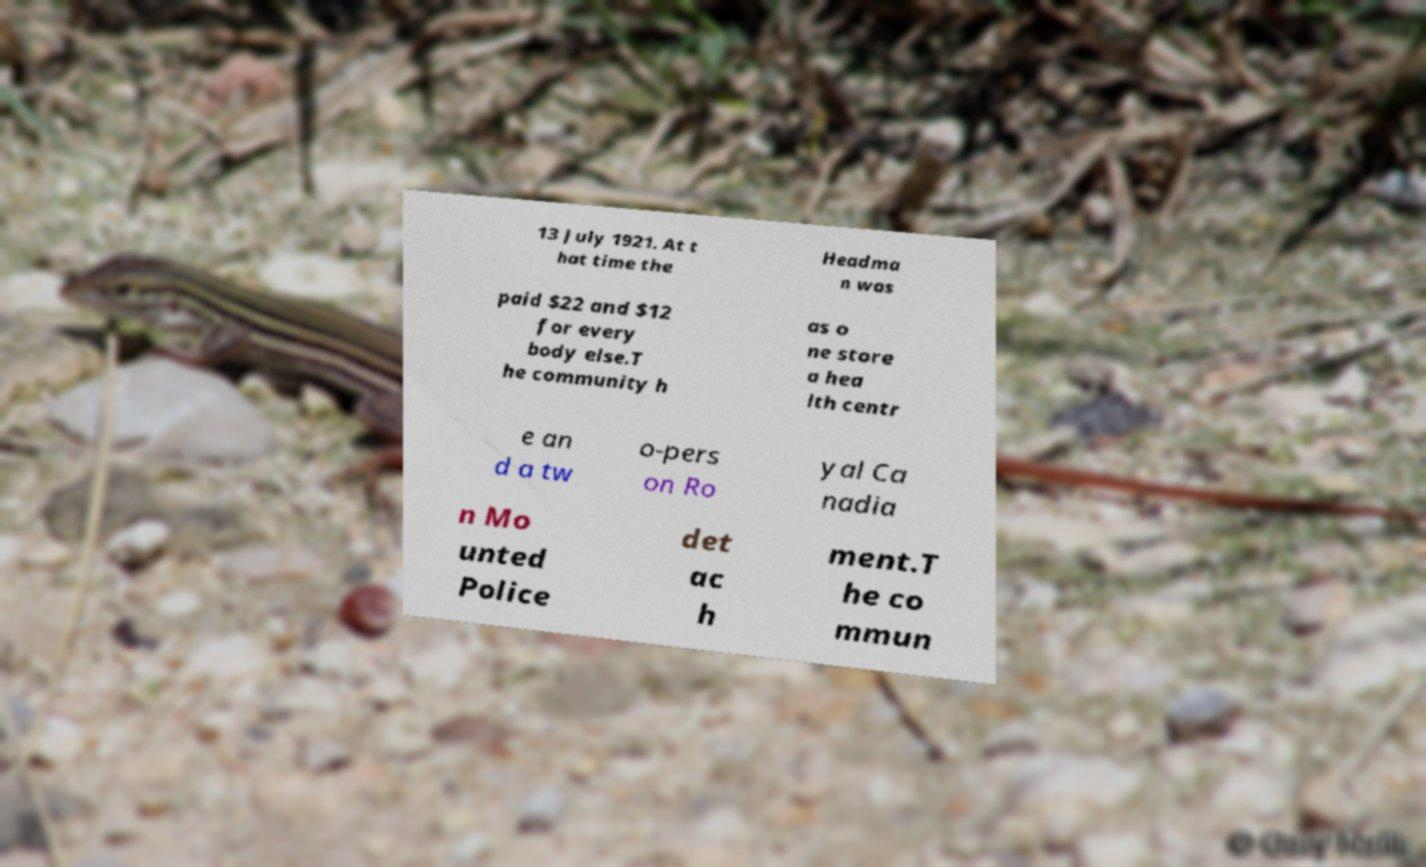Please identify and transcribe the text found in this image. 13 July 1921. At t hat time the Headma n was paid $22 and $12 for every body else.T he community h as o ne store a hea lth centr e an d a tw o-pers on Ro yal Ca nadia n Mo unted Police det ac h ment.T he co mmun 